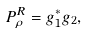<formula> <loc_0><loc_0><loc_500><loc_500>P _ { \rho } ^ { R } = g _ { 1 } ^ { \ast } g _ { 2 } ,</formula> 